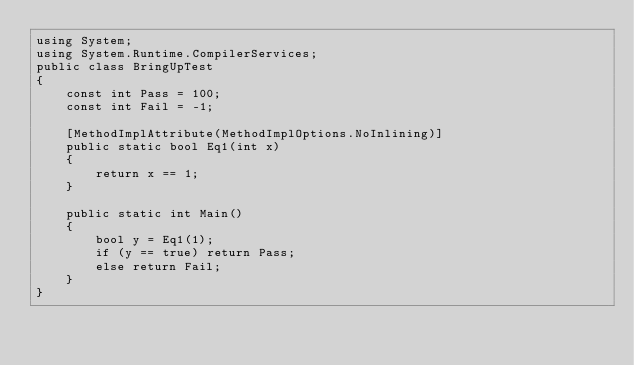Convert code to text. <code><loc_0><loc_0><loc_500><loc_500><_C#_>using System;
using System.Runtime.CompilerServices;
public class BringUpTest
{
    const int Pass = 100;
    const int Fail = -1;

    [MethodImplAttribute(MethodImplOptions.NoInlining)]
    public static bool Eq1(int x)
    {
        return x == 1;
    }

    public static int Main()
    {
        bool y = Eq1(1);
        if (y == true) return Pass;
        else return Fail;
    }
}
</code> 